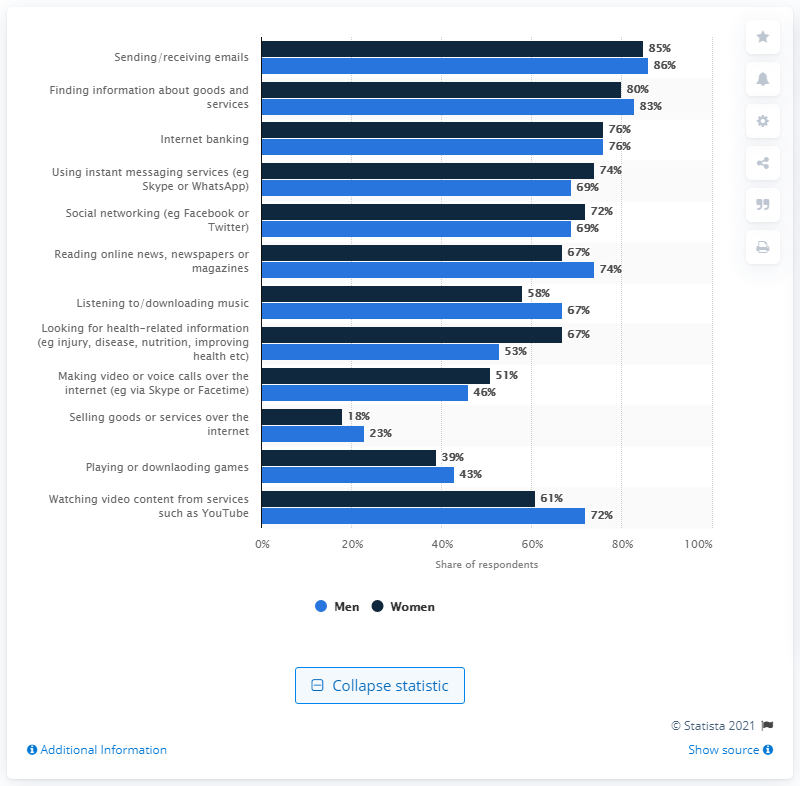Specify some key components in this picture. The average of the lowest activity in men and the highest activity in men is 54.5. Sending or receiving emails has the highest share of respondents among all activities. 